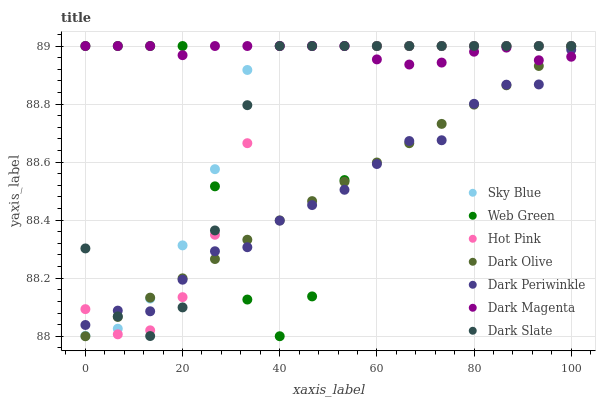Does Dark Periwinkle have the minimum area under the curve?
Answer yes or no. Yes. Does Dark Magenta have the maximum area under the curve?
Answer yes or no. Yes. Does Dark Olive have the minimum area under the curve?
Answer yes or no. No. Does Dark Olive have the maximum area under the curve?
Answer yes or no. No. Is Dark Olive the smoothest?
Answer yes or no. Yes. Is Web Green the roughest?
Answer yes or no. Yes. Is Dark Magenta the smoothest?
Answer yes or no. No. Is Dark Magenta the roughest?
Answer yes or no. No. Does Dark Olive have the lowest value?
Answer yes or no. Yes. Does Dark Magenta have the lowest value?
Answer yes or no. No. Does Sky Blue have the highest value?
Answer yes or no. Yes. Does Dark Olive have the highest value?
Answer yes or no. No. Does Web Green intersect Dark Periwinkle?
Answer yes or no. Yes. Is Web Green less than Dark Periwinkle?
Answer yes or no. No. Is Web Green greater than Dark Periwinkle?
Answer yes or no. No. 